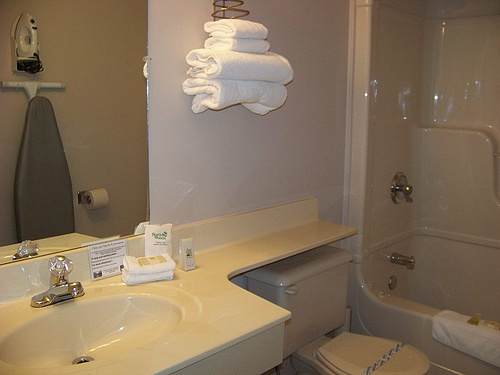Describe the objects in this image and their specific colors. I can see sink in black and tan tones and toilet in black, gray, and maroon tones in this image. 